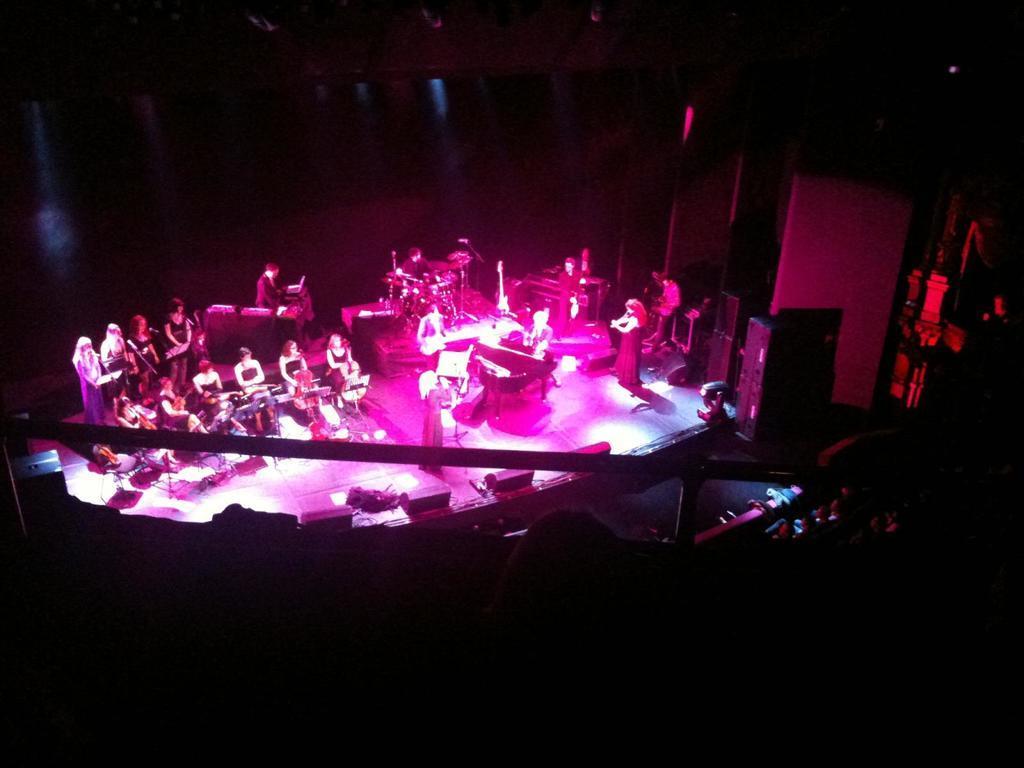In one or two sentences, can you explain what this image depicts? In this image we can see a group of people standing on the ground, a group of musical instruments placed on the ground. One woman is holding a microphone in her hand. In the center of the image we can see group of speakers and lights placed on the stage. In the foreground we can see some people and a metal railing. 